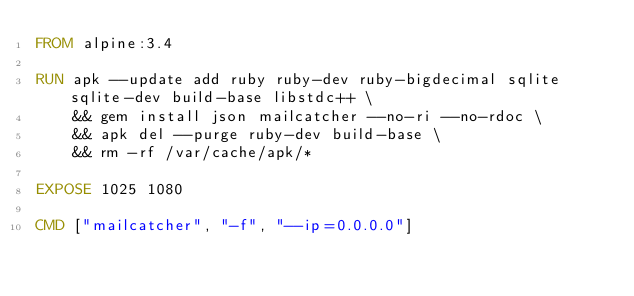<code> <loc_0><loc_0><loc_500><loc_500><_Dockerfile_>FROM alpine:3.4

RUN apk --update add ruby ruby-dev ruby-bigdecimal sqlite sqlite-dev build-base libstdc++ \
    && gem install json mailcatcher --no-ri --no-rdoc \
    && apk del --purge ruby-dev build-base \
    && rm -rf /var/cache/apk/*

EXPOSE 1025 1080

CMD ["mailcatcher", "-f", "--ip=0.0.0.0"]
</code> 